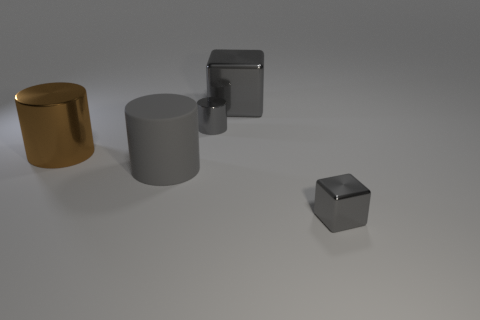The other gray object that is the same shape as the matte object is what size?
Make the answer very short. Small. Is the number of tiny gray things that are in front of the gray metal cylinder greater than the number of tiny red metallic objects?
Make the answer very short. Yes. Is the small cube made of the same material as the small cylinder?
Offer a terse response. Yes. What number of objects are either small gray cubes that are to the right of the big brown cylinder or cylinders behind the big brown metal cylinder?
Provide a succinct answer. 2. There is a small metal object that is the same shape as the big gray metal thing; what is its color?
Your response must be concise. Gray. How many large cylinders have the same color as the big metal block?
Provide a succinct answer. 1. Is the large matte cylinder the same color as the big cube?
Ensure brevity in your answer.  Yes. What number of objects are either large blocks behind the tiny gray metallic cube or large brown objects?
Provide a succinct answer. 2. What is the color of the metal cube behind the tiny object behind the small metal thing that is to the right of the big gray metal thing?
Provide a succinct answer. Gray. There is a cylinder that is made of the same material as the brown object; what is its color?
Make the answer very short. Gray. 